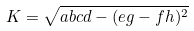<formula> <loc_0><loc_0><loc_500><loc_500>K = \sqrt { a b c d - ( e g - f h ) ^ { 2 } }</formula> 